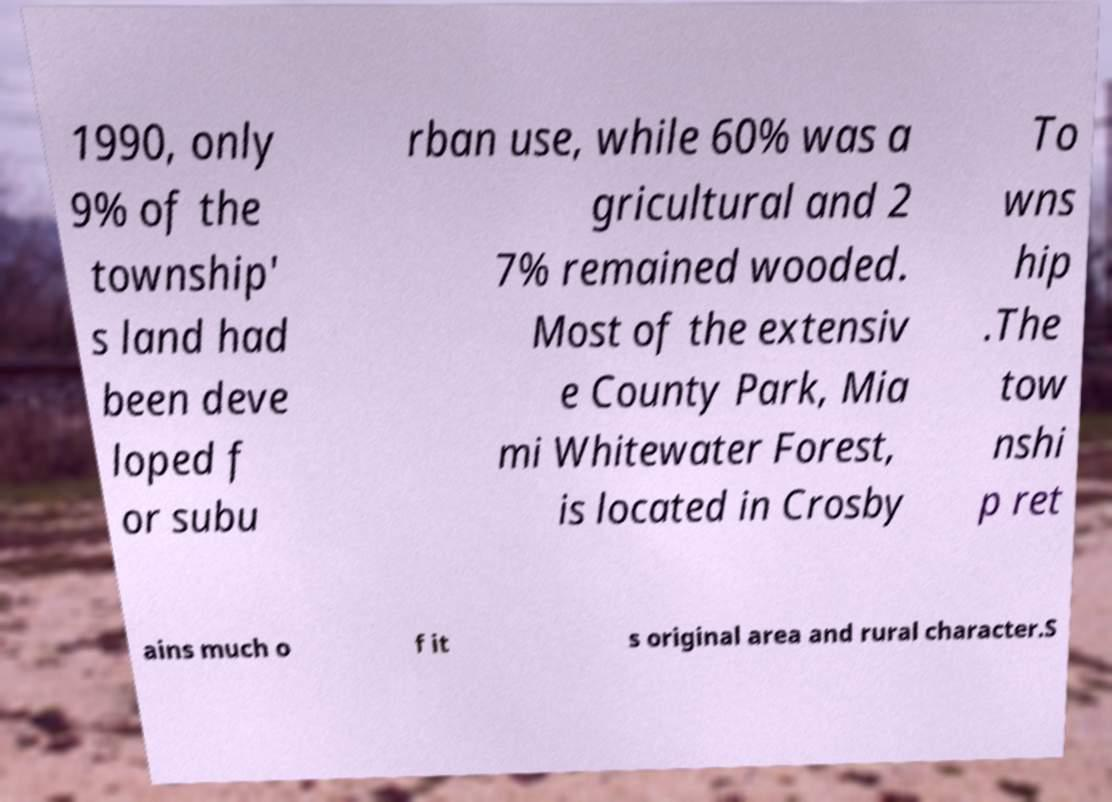Can you accurately transcribe the text from the provided image for me? 1990, only 9% of the township' s land had been deve loped f or subu rban use, while 60% was a gricultural and 2 7% remained wooded. Most of the extensiv e County Park, Mia mi Whitewater Forest, is located in Crosby To wns hip .The tow nshi p ret ains much o f it s original area and rural character.S 